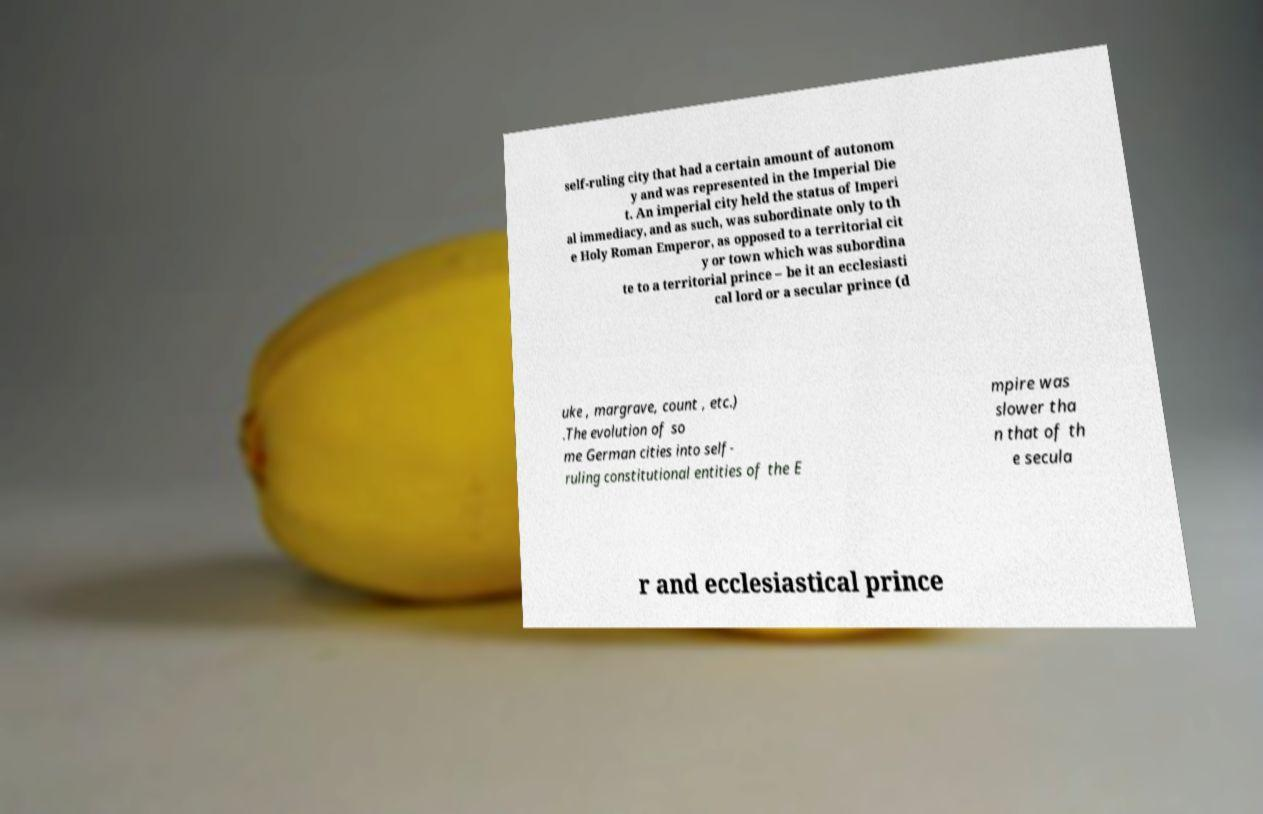Please identify and transcribe the text found in this image. self-ruling city that had a certain amount of autonom y and was represented in the Imperial Die t. An imperial city held the status of Imperi al immediacy, and as such, was subordinate only to th e Holy Roman Emperor, as opposed to a territorial cit y or town which was subordina te to a territorial prince – be it an ecclesiasti cal lord or a secular prince (d uke , margrave, count , etc.) .The evolution of so me German cities into self- ruling constitutional entities of the E mpire was slower tha n that of th e secula r and ecclesiastical prince 